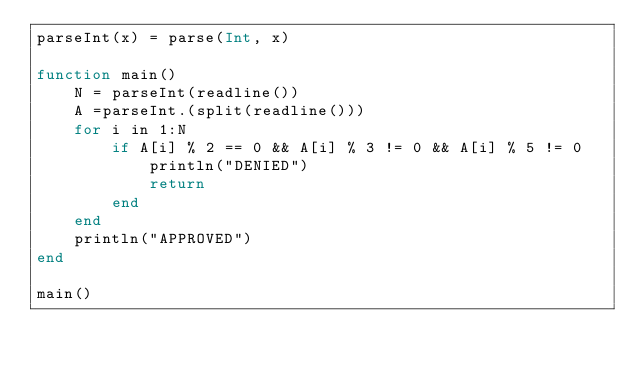Convert code to text. <code><loc_0><loc_0><loc_500><loc_500><_Julia_>parseInt(x) = parse(Int, x)

function main()
    N = parseInt(readline())
    A =parseInt.(split(readline()))
    for i in 1:N
        if A[i] % 2 == 0 && A[i] % 3 != 0 && A[i] % 5 != 0
            println("DENIED")
            return
        end
    end
    println("APPROVED")
end

main()</code> 